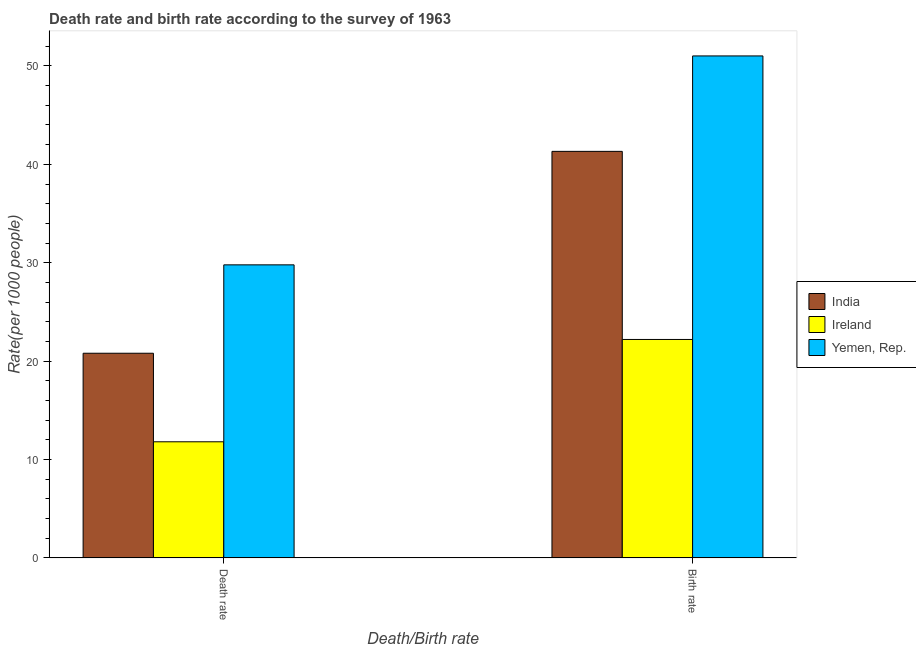Are the number of bars per tick equal to the number of legend labels?
Provide a succinct answer. Yes. Are the number of bars on each tick of the X-axis equal?
Offer a terse response. Yes. How many bars are there on the 1st tick from the left?
Ensure brevity in your answer.  3. What is the label of the 2nd group of bars from the left?
Provide a succinct answer. Birth rate. What is the death rate in India?
Your response must be concise. 20.8. Across all countries, what is the maximum birth rate?
Your answer should be compact. 51.02. In which country was the death rate maximum?
Keep it short and to the point. Yemen, Rep. In which country was the death rate minimum?
Give a very brief answer. Ireland. What is the total birth rate in the graph?
Offer a terse response. 114.53. What is the difference between the birth rate in Yemen, Rep. and that in Ireland?
Your answer should be compact. 28.82. What is the difference between the birth rate in India and the death rate in Ireland?
Your answer should be compact. 29.52. What is the average death rate per country?
Provide a short and direct response. 20.79. What is the difference between the birth rate and death rate in Ireland?
Your answer should be compact. 10.4. In how many countries, is the birth rate greater than 12 ?
Make the answer very short. 3. What is the ratio of the death rate in Ireland to that in Yemen, Rep.?
Keep it short and to the point. 0.4. In how many countries, is the birth rate greater than the average birth rate taken over all countries?
Your response must be concise. 2. What does the 3rd bar from the left in Birth rate represents?
Your answer should be very brief. Yemen, Rep. What does the 1st bar from the right in Birth rate represents?
Ensure brevity in your answer.  Yemen, Rep. How many bars are there?
Your answer should be compact. 6. Where does the legend appear in the graph?
Ensure brevity in your answer.  Center right. How are the legend labels stacked?
Offer a terse response. Vertical. What is the title of the graph?
Your response must be concise. Death rate and birth rate according to the survey of 1963. What is the label or title of the X-axis?
Your answer should be very brief. Death/Birth rate. What is the label or title of the Y-axis?
Your answer should be compact. Rate(per 1000 people). What is the Rate(per 1000 people) in India in Death rate?
Your answer should be very brief. 20.8. What is the Rate(per 1000 people) of Yemen, Rep. in Death rate?
Your answer should be very brief. 29.78. What is the Rate(per 1000 people) in India in Birth rate?
Your answer should be very brief. 41.32. What is the Rate(per 1000 people) of Yemen, Rep. in Birth rate?
Provide a short and direct response. 51.02. Across all Death/Birth rate, what is the maximum Rate(per 1000 people) in India?
Make the answer very short. 41.32. Across all Death/Birth rate, what is the maximum Rate(per 1000 people) in Ireland?
Your response must be concise. 22.2. Across all Death/Birth rate, what is the maximum Rate(per 1000 people) in Yemen, Rep.?
Offer a very short reply. 51.02. Across all Death/Birth rate, what is the minimum Rate(per 1000 people) of India?
Ensure brevity in your answer.  20.8. Across all Death/Birth rate, what is the minimum Rate(per 1000 people) in Yemen, Rep.?
Offer a very short reply. 29.78. What is the total Rate(per 1000 people) of India in the graph?
Give a very brief answer. 62.12. What is the total Rate(per 1000 people) of Yemen, Rep. in the graph?
Make the answer very short. 80.8. What is the difference between the Rate(per 1000 people) in India in Death rate and that in Birth rate?
Your answer should be very brief. -20.52. What is the difference between the Rate(per 1000 people) in Yemen, Rep. in Death rate and that in Birth rate?
Provide a succinct answer. -21.23. What is the difference between the Rate(per 1000 people) in India in Death rate and the Rate(per 1000 people) in Ireland in Birth rate?
Offer a terse response. -1.4. What is the difference between the Rate(per 1000 people) in India in Death rate and the Rate(per 1000 people) in Yemen, Rep. in Birth rate?
Your response must be concise. -30.22. What is the difference between the Rate(per 1000 people) in Ireland in Death rate and the Rate(per 1000 people) in Yemen, Rep. in Birth rate?
Your answer should be compact. -39.22. What is the average Rate(per 1000 people) in India per Death/Birth rate?
Keep it short and to the point. 31.06. What is the average Rate(per 1000 people) in Ireland per Death/Birth rate?
Ensure brevity in your answer.  17. What is the average Rate(per 1000 people) of Yemen, Rep. per Death/Birth rate?
Offer a terse response. 40.4. What is the difference between the Rate(per 1000 people) in India and Rate(per 1000 people) in Ireland in Death rate?
Offer a terse response. 9. What is the difference between the Rate(per 1000 people) of India and Rate(per 1000 people) of Yemen, Rep. in Death rate?
Give a very brief answer. -8.98. What is the difference between the Rate(per 1000 people) in Ireland and Rate(per 1000 people) in Yemen, Rep. in Death rate?
Give a very brief answer. -17.98. What is the difference between the Rate(per 1000 people) in India and Rate(per 1000 people) in Ireland in Birth rate?
Make the answer very short. 19.12. What is the difference between the Rate(per 1000 people) in India and Rate(per 1000 people) in Yemen, Rep. in Birth rate?
Ensure brevity in your answer.  -9.7. What is the difference between the Rate(per 1000 people) in Ireland and Rate(per 1000 people) in Yemen, Rep. in Birth rate?
Offer a terse response. -28.82. What is the ratio of the Rate(per 1000 people) in India in Death rate to that in Birth rate?
Provide a short and direct response. 0.5. What is the ratio of the Rate(per 1000 people) of Ireland in Death rate to that in Birth rate?
Provide a succinct answer. 0.53. What is the ratio of the Rate(per 1000 people) in Yemen, Rep. in Death rate to that in Birth rate?
Provide a succinct answer. 0.58. What is the difference between the highest and the second highest Rate(per 1000 people) in India?
Give a very brief answer. 20.52. What is the difference between the highest and the second highest Rate(per 1000 people) in Ireland?
Make the answer very short. 10.4. What is the difference between the highest and the second highest Rate(per 1000 people) in Yemen, Rep.?
Give a very brief answer. 21.23. What is the difference between the highest and the lowest Rate(per 1000 people) of India?
Ensure brevity in your answer.  20.52. What is the difference between the highest and the lowest Rate(per 1000 people) in Ireland?
Your answer should be compact. 10.4. What is the difference between the highest and the lowest Rate(per 1000 people) of Yemen, Rep.?
Your answer should be compact. 21.23. 